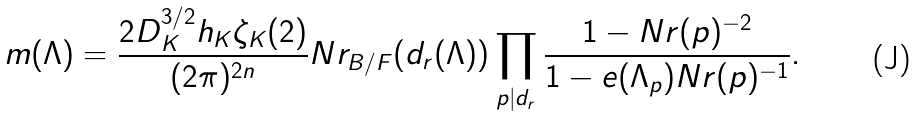Convert formula to latex. <formula><loc_0><loc_0><loc_500><loc_500>m ( \Lambda ) = \frac { 2 D _ { K } ^ { 3 / 2 } h _ { K } \zeta _ { K } ( 2 ) } { ( 2 \pi ) ^ { 2 n } } N r _ { B / F } ( d _ { r } ( \Lambda ) ) \prod _ { p | d _ { r } } \frac { 1 - N r ( p ) ^ { - 2 } } { 1 - e ( \Lambda _ { p } ) N r ( p ) ^ { - 1 } } .</formula> 